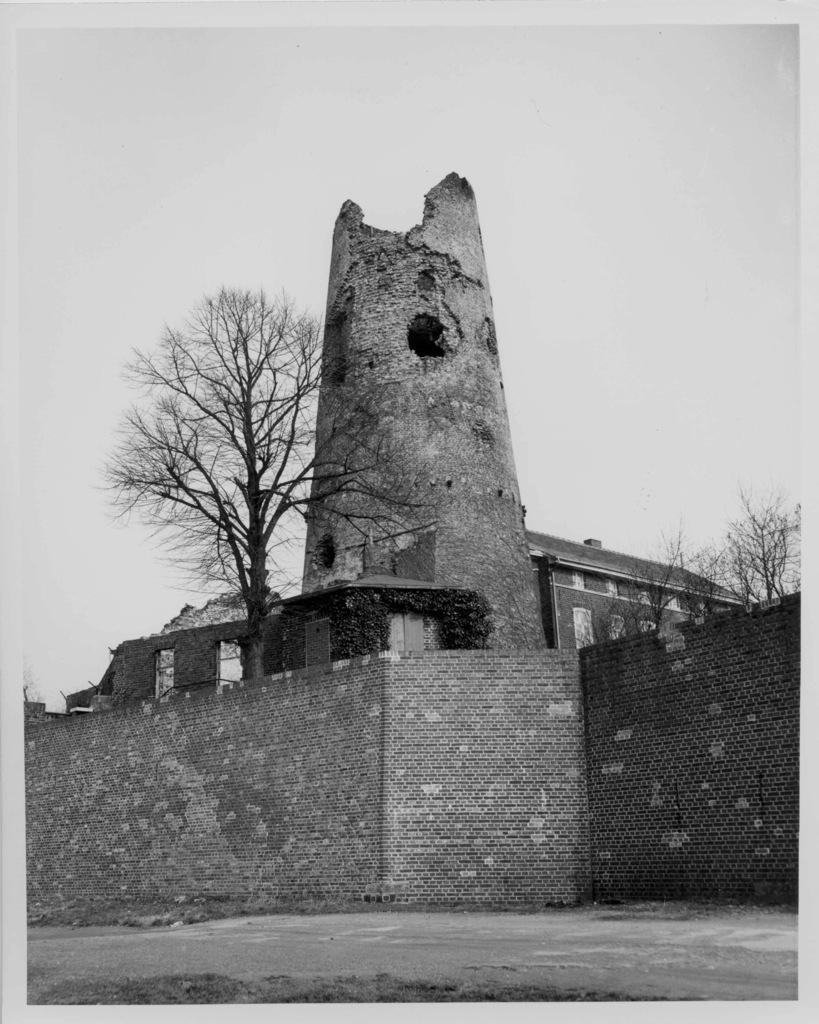What is located in the foreground of the image? There is a wall and a building in the foreground of the image. What type of vegetation can be seen in the image? Trees are visible in the image. What part of the natural environment is visible in the image? The sky is visible in the image. Can you tell me how many crows are sitting on the plate in the image? There is no plate or crows present in the image. What type of expert can be seen giving a lecture in the image? There is no expert or lecture depicted in the image. 